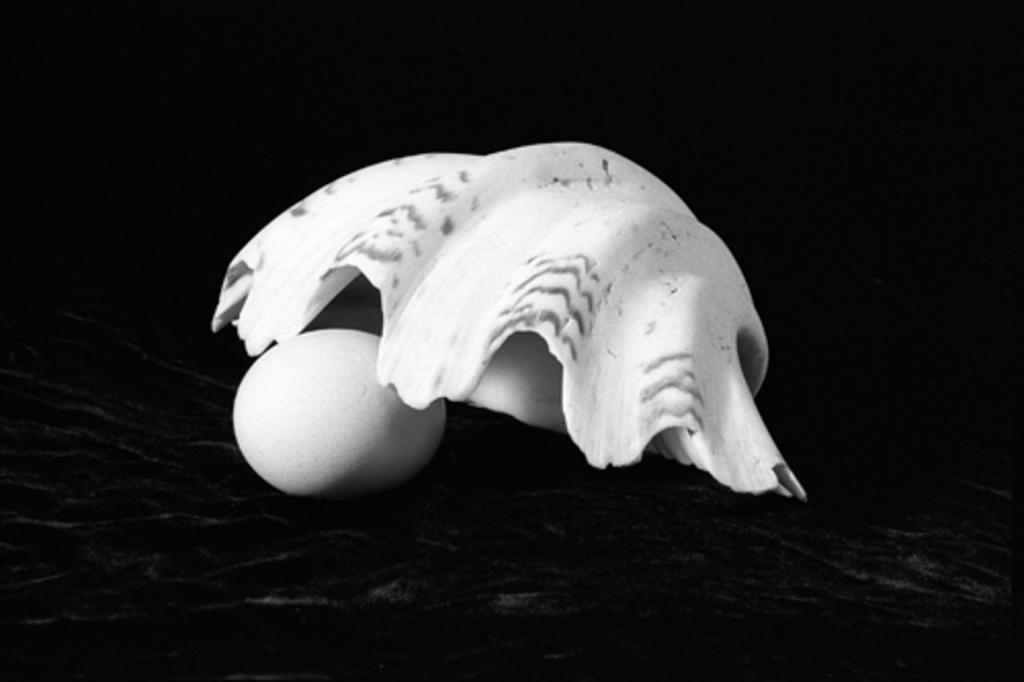What is the main subject of the image? The main subject of the image is an egg. Is there any other object in the image besides the egg? Yes, there is a white color object placed above the egg. What direction is the clam facing in the image? There is no clam present in the image; it only features an egg and a white color object. 